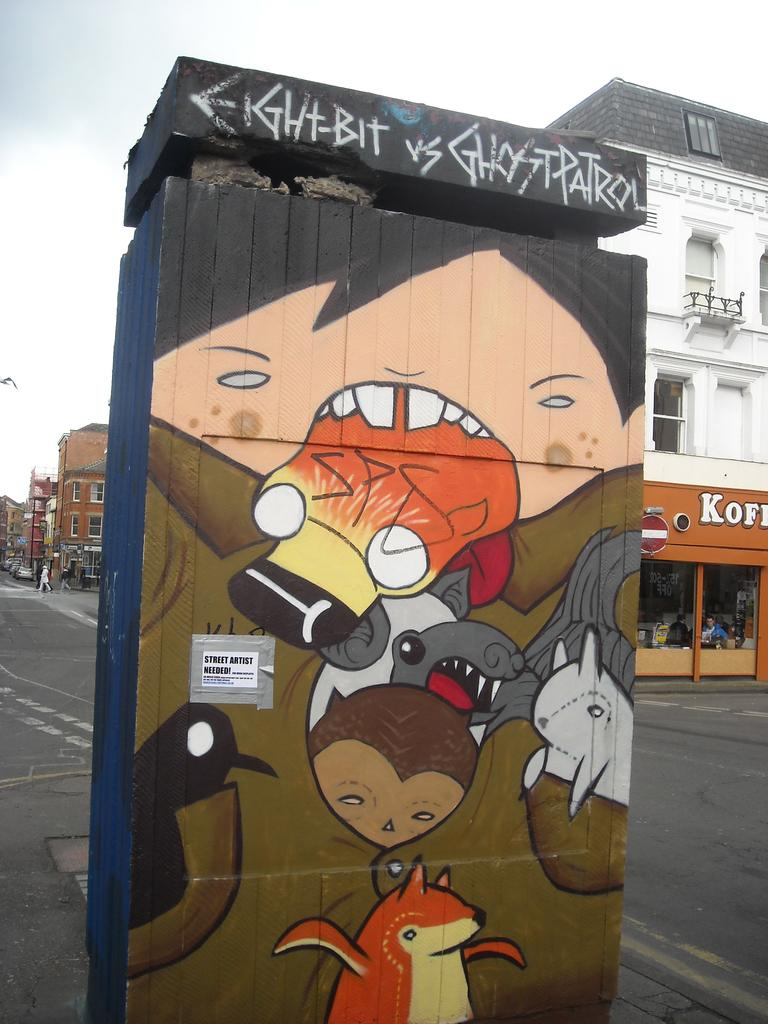What object is the main focus of the image? There is a wooden box in the image. What design is on the wooden box? The wooden box has cartoon pictures on it. What can be seen in the distance in the image? There is a road, buildings, and the sky visible in the background of the image. What type of teeth can be seen on the man in the image? There is no man present in the image, so it is not possible to determine what type of teeth might be seen. 